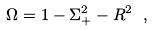<formula> <loc_0><loc_0><loc_500><loc_500>\Omega = 1 - \Sigma _ { + } ^ { 2 } - R ^ { 2 } \ ,</formula> 